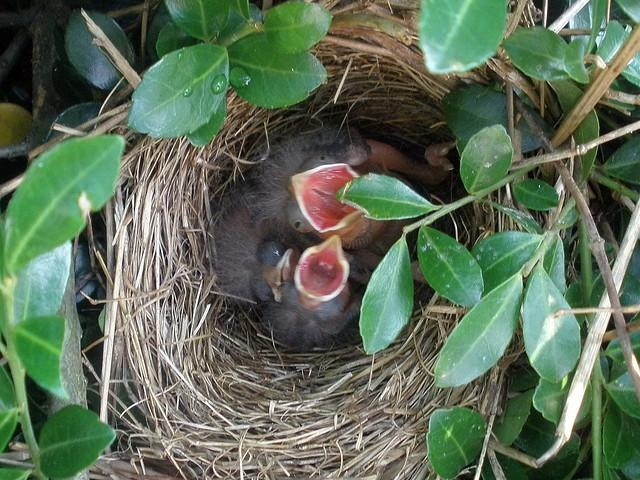Why are their mouths open?

Choices:
A) talking
B) drinking
C) hunting
D) hungry hungry 